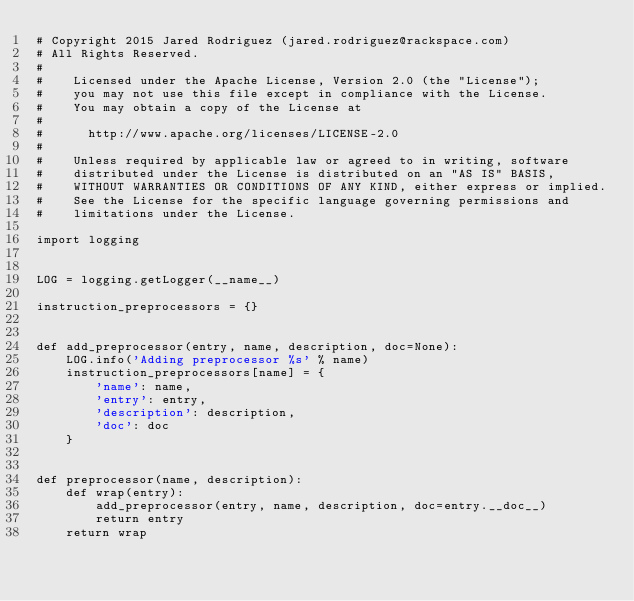Convert code to text. <code><loc_0><loc_0><loc_500><loc_500><_Python_># Copyright 2015 Jared Rodriguez (jared.rodriguez@rackspace.com)
# All Rights Reserved.
#
#    Licensed under the Apache License, Version 2.0 (the "License");
#    you may not use this file except in compliance with the License.
#    You may obtain a copy of the License at
#
#      http://www.apache.org/licenses/LICENSE-2.0
#
#    Unless required by applicable law or agreed to in writing, software
#    distributed under the License is distributed on an "AS IS" BASIS,
#    WITHOUT WARRANTIES OR CONDITIONS OF ANY KIND, either express or implied.
#    See the License for the specific language governing permissions and
#    limitations under the License.

import logging


LOG = logging.getLogger(__name__)

instruction_preprocessors = {}


def add_preprocessor(entry, name, description, doc=None):
    LOG.info('Adding preprocessor %s' % name)
    instruction_preprocessors[name] = {
        'name': name,
        'entry': entry,
        'description': description,
        'doc': doc
    }


def preprocessor(name, description):
    def wrap(entry):
        add_preprocessor(entry, name, description, doc=entry.__doc__)
        return entry
    return wrap

</code> 